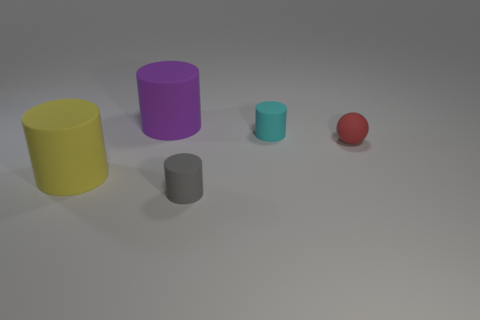What could be the possible use of these objects in a real-world setting? These objects could serve a variety of educational or illustrative purposes. For instance, they could be used in a physics class to discuss concepts like volume, surface area, and geometry, or be part of a 3D modeling exercise for a course in graphic design or animation, teaching students about shading, lighting, and perspectives. 